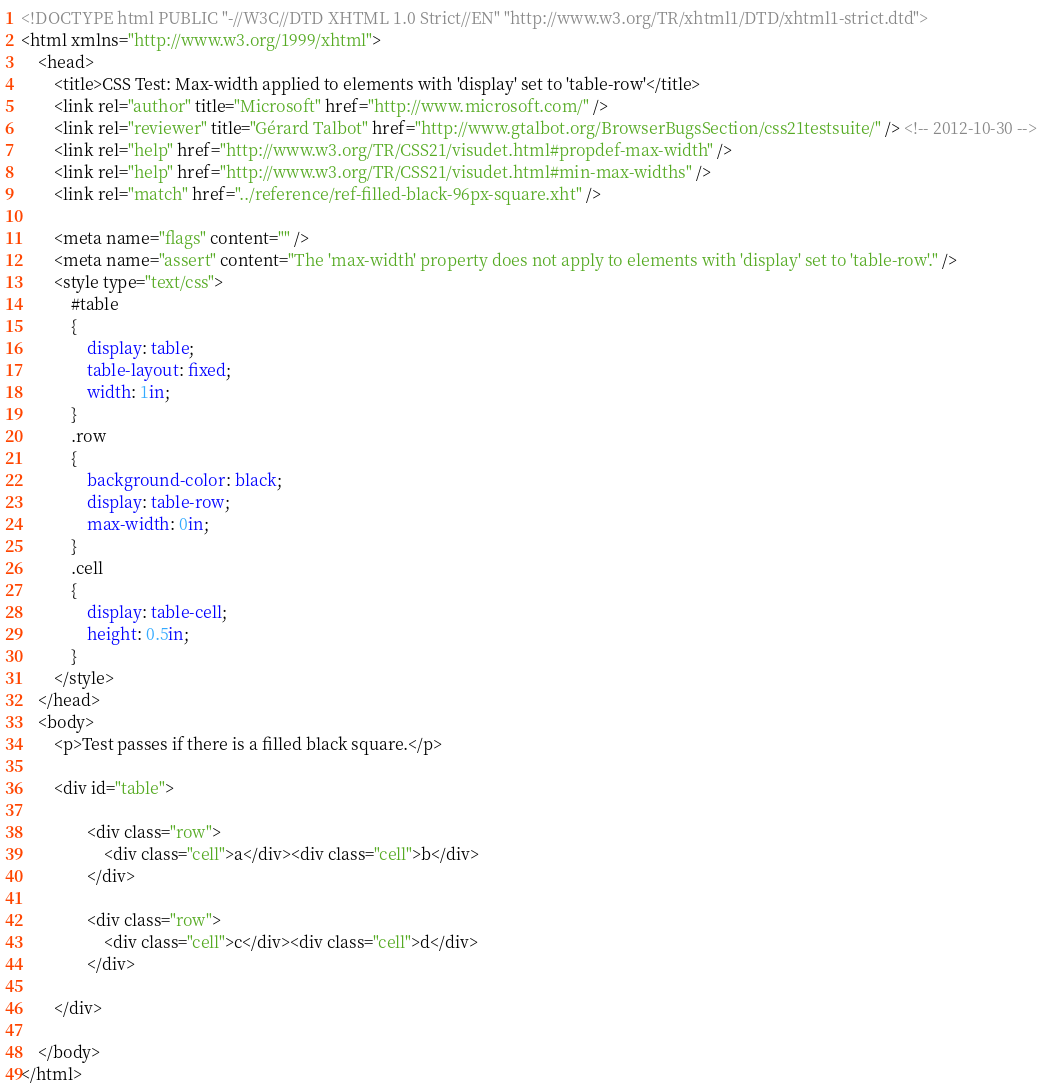<code> <loc_0><loc_0><loc_500><loc_500><_HTML_><!DOCTYPE html PUBLIC "-//W3C//DTD XHTML 1.0 Strict//EN" "http://www.w3.org/TR/xhtml1/DTD/xhtml1-strict.dtd">
<html xmlns="http://www.w3.org/1999/xhtml">
    <head>
        <title>CSS Test: Max-width applied to elements with 'display' set to 'table-row'</title>
        <link rel="author" title="Microsoft" href="http://www.microsoft.com/" />
        <link rel="reviewer" title="Gérard Talbot" href="http://www.gtalbot.org/BrowserBugsSection/css21testsuite/" /> <!-- 2012-10-30 -->
        <link rel="help" href="http://www.w3.org/TR/CSS21/visudet.html#propdef-max-width" />
        <link rel="help" href="http://www.w3.org/TR/CSS21/visudet.html#min-max-widths" />
        <link rel="match" href="../reference/ref-filled-black-96px-square.xht" />

        <meta name="flags" content="" />
        <meta name="assert" content="The 'max-width' property does not apply to elements with 'display' set to 'table-row'." />
        <style type="text/css">
            #table
            {
                display: table;
                table-layout: fixed;
                width: 1in;
            }
            .row
            {
                background-color: black;
                display: table-row;
                max-width: 0in;
            }
            .cell
            {
                display: table-cell;
                height: 0.5in;
            }
        </style>
    </head>
    <body>
        <p>Test passes if there is a filled black square.</p>

        <div id="table">

                <div class="row">
                    <div class="cell">a</div><div class="cell">b</div>
                </div>

                <div class="row">
                    <div class="cell">c</div><div class="cell">d</div>
                </div>

        </div>

    </body>
</html></code> 